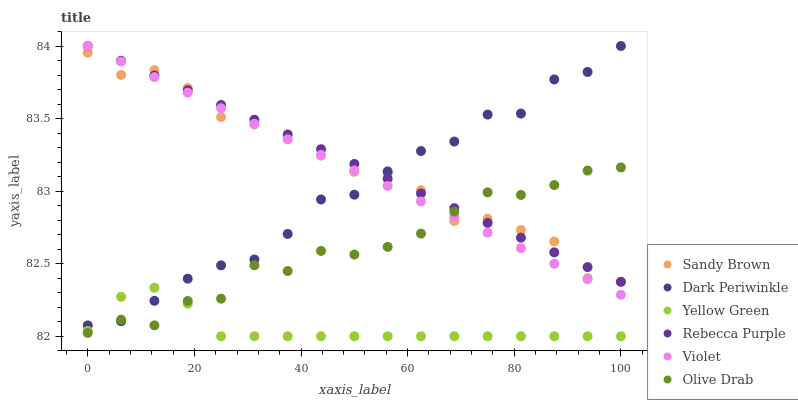Does Yellow Green have the minimum area under the curve?
Answer yes or no. Yes. Does Rebecca Purple have the maximum area under the curve?
Answer yes or no. Yes. Does Violet have the minimum area under the curve?
Answer yes or no. No. Does Violet have the maximum area under the curve?
Answer yes or no. No. Is Violet the smoothest?
Answer yes or no. Yes. Is Olive Drab the roughest?
Answer yes or no. Yes. Is Rebecca Purple the smoothest?
Answer yes or no. No. Is Rebecca Purple the roughest?
Answer yes or no. No. Does Yellow Green have the lowest value?
Answer yes or no. Yes. Does Rebecca Purple have the lowest value?
Answer yes or no. No. Does Dark Periwinkle have the highest value?
Answer yes or no. Yes. Does Sandy Brown have the highest value?
Answer yes or no. No. Is Yellow Green less than Sandy Brown?
Answer yes or no. Yes. Is Rebecca Purple greater than Yellow Green?
Answer yes or no. Yes. Does Rebecca Purple intersect Violet?
Answer yes or no. Yes. Is Rebecca Purple less than Violet?
Answer yes or no. No. Is Rebecca Purple greater than Violet?
Answer yes or no. No. Does Yellow Green intersect Sandy Brown?
Answer yes or no. No. 